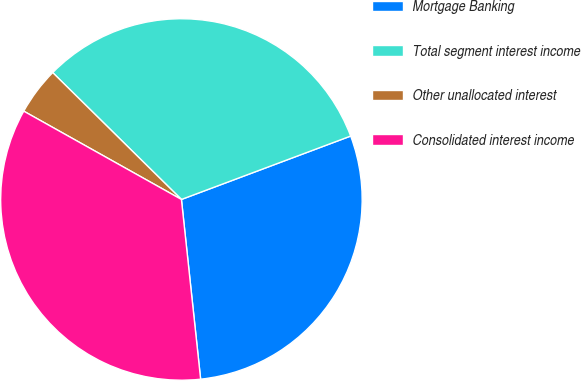Convert chart to OTSL. <chart><loc_0><loc_0><loc_500><loc_500><pie_chart><fcel>Mortgage Banking<fcel>Total segment interest income<fcel>Other unallocated interest<fcel>Consolidated interest income<nl><fcel>29.01%<fcel>31.91%<fcel>4.26%<fcel>34.82%<nl></chart> 